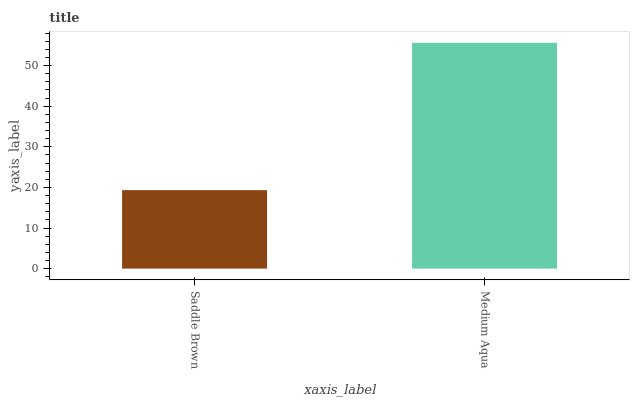Is Medium Aqua the minimum?
Answer yes or no. No. Is Medium Aqua greater than Saddle Brown?
Answer yes or no. Yes. Is Saddle Brown less than Medium Aqua?
Answer yes or no. Yes. Is Saddle Brown greater than Medium Aqua?
Answer yes or no. No. Is Medium Aqua less than Saddle Brown?
Answer yes or no. No. Is Medium Aqua the high median?
Answer yes or no. Yes. Is Saddle Brown the low median?
Answer yes or no. Yes. Is Saddle Brown the high median?
Answer yes or no. No. Is Medium Aqua the low median?
Answer yes or no. No. 